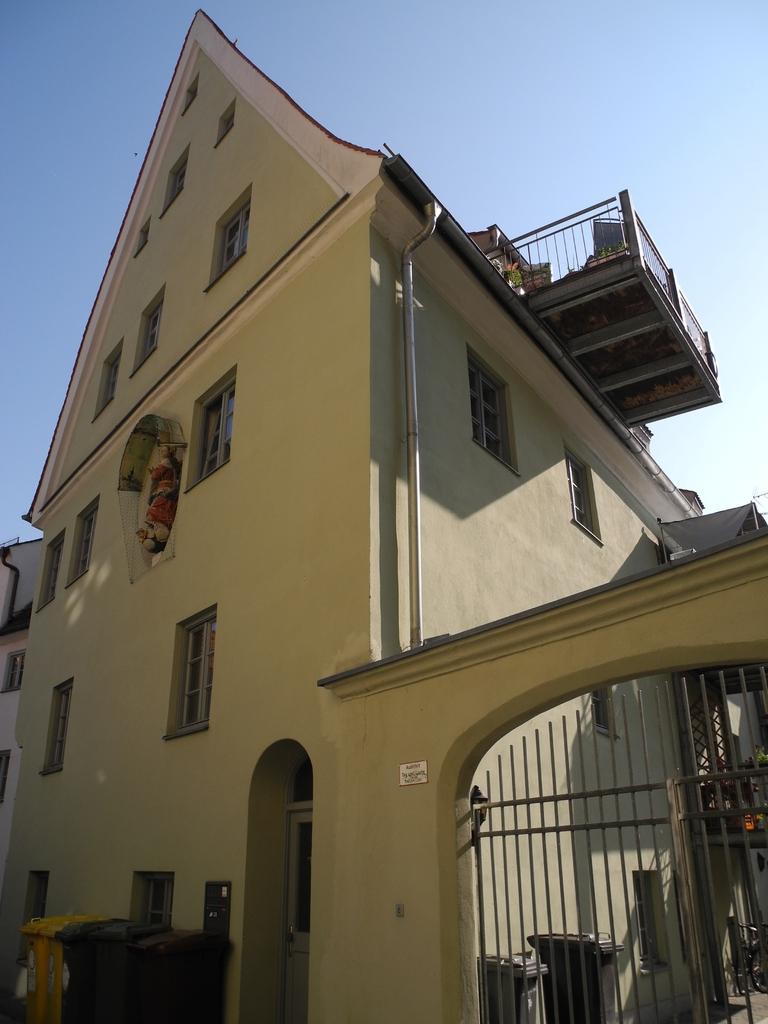Can you describe this image briefly? In this image I can see the building which is cream in color, few windows of the building, few pipes and the metal gate. I can see few dustbins and a bicycle on the ground. To the top of the image I can see the sky. 